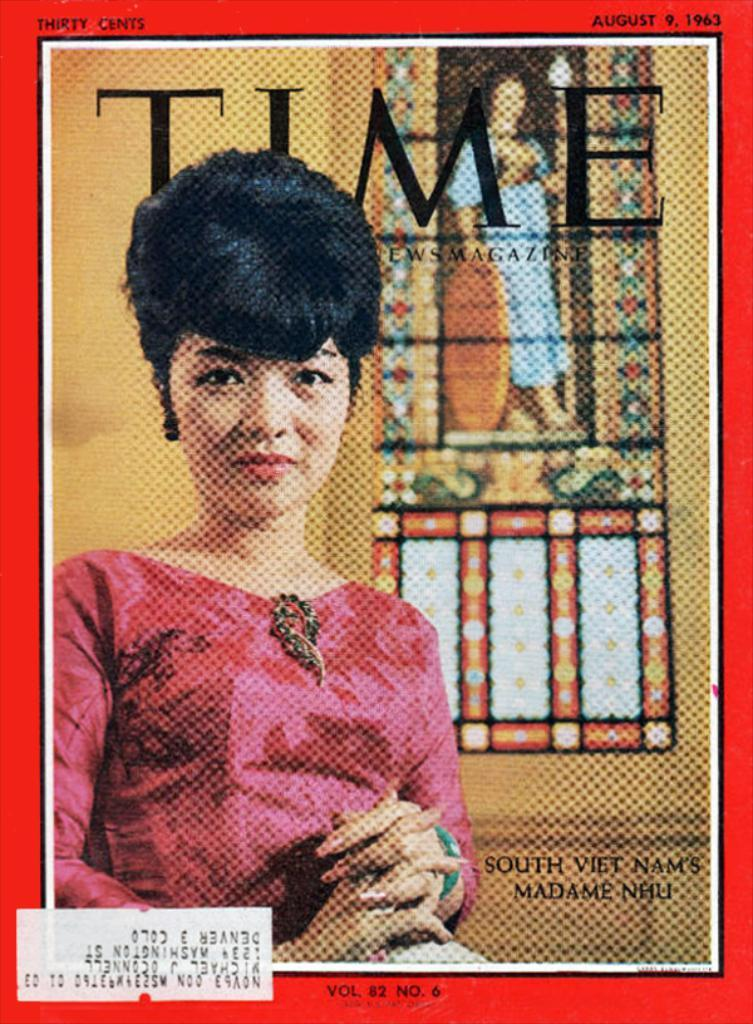What is the main object in the image? There is a poster in the image. What can be seen on the poster? There are people depicted on the poster, and there is text on the poster. How many plants are visible on the poster? There are no plants visible on the poster; it features people and text. What type of lizards can be seen interacting with the people on the poster? There are no lizards present on the poster; it only features people and text. 